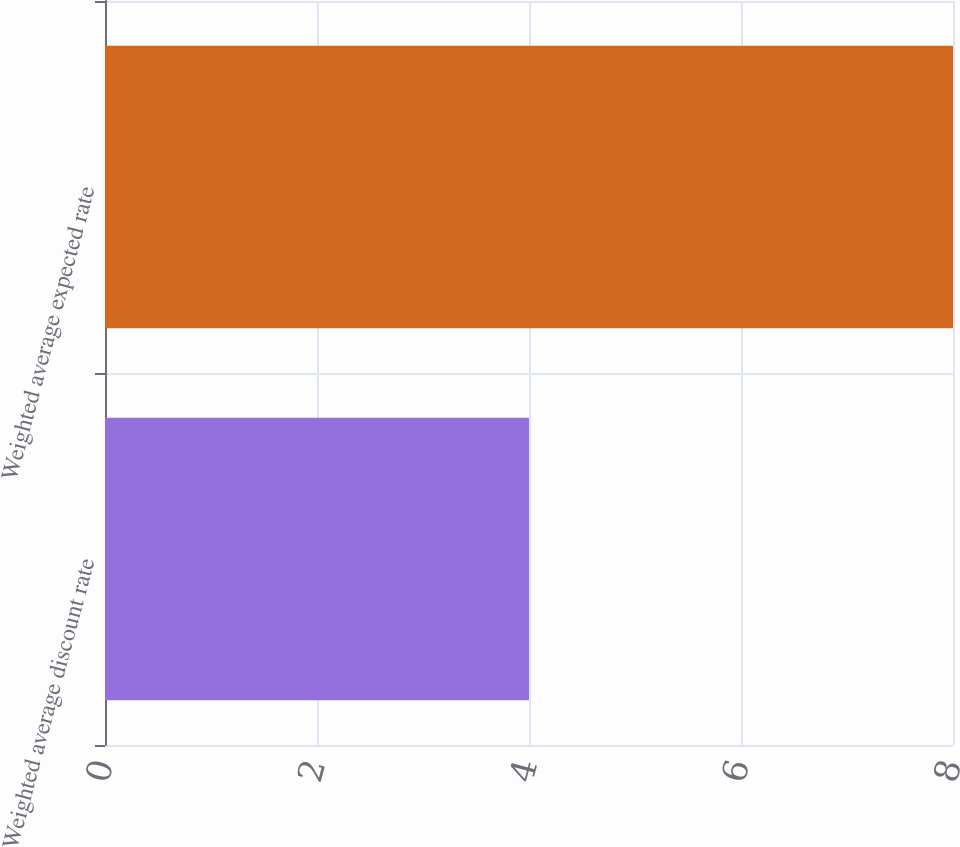Convert chart. <chart><loc_0><loc_0><loc_500><loc_500><bar_chart><fcel>Weighted average discount rate<fcel>Weighted average expected rate<nl><fcel>4<fcel>8<nl></chart> 